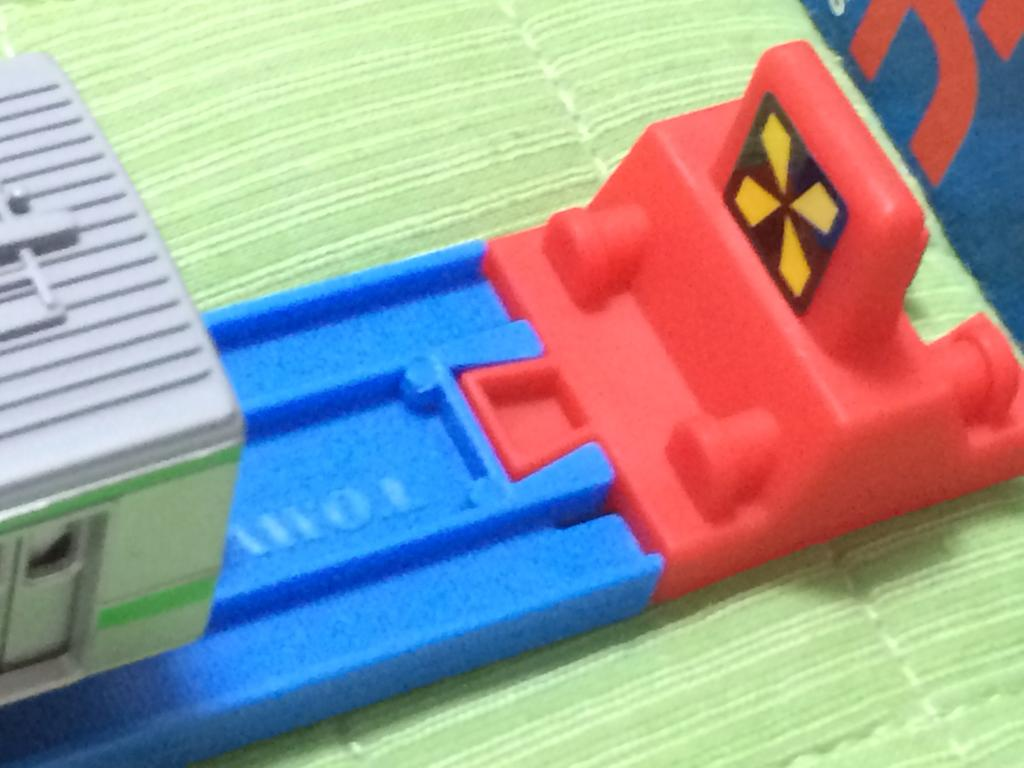What types of items can be seen in the image? There are objects in the image. Can you describe the appearance of these objects? The objects are in different colors and resemble plastic toys. How many mice are sitting on the pies in the image? There are no mice or pies present in the image; it features objects that resemble plastic toys in different colors. 